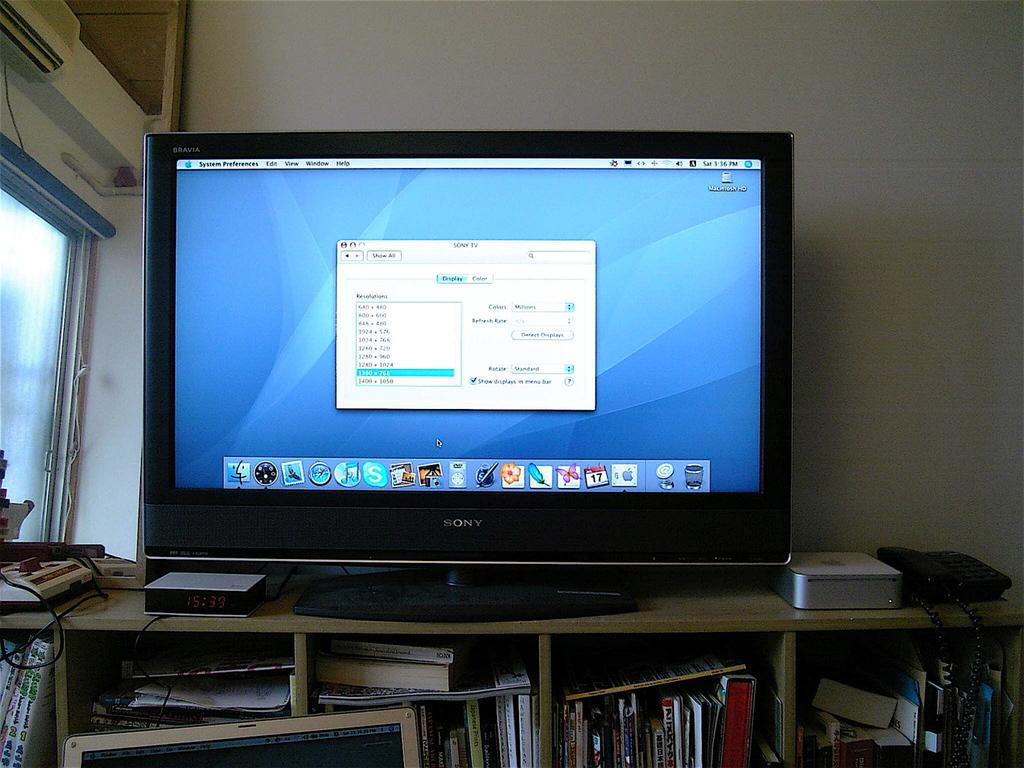<image>
Write a terse but informative summary of the picture. A monitor that is turned on which is from the brand Sony. 